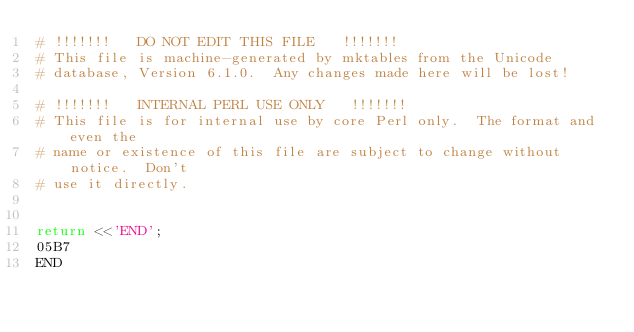Convert code to text. <code><loc_0><loc_0><loc_500><loc_500><_Perl_># !!!!!!!   DO NOT EDIT THIS FILE   !!!!!!!
# This file is machine-generated by mktables from the Unicode
# database, Version 6.1.0.  Any changes made here will be lost!

# !!!!!!!   INTERNAL PERL USE ONLY   !!!!!!!
# This file is for internal use by core Perl only.  The format and even the
# name or existence of this file are subject to change without notice.  Don't
# use it directly.


return <<'END';
05B7		
END
</code> 